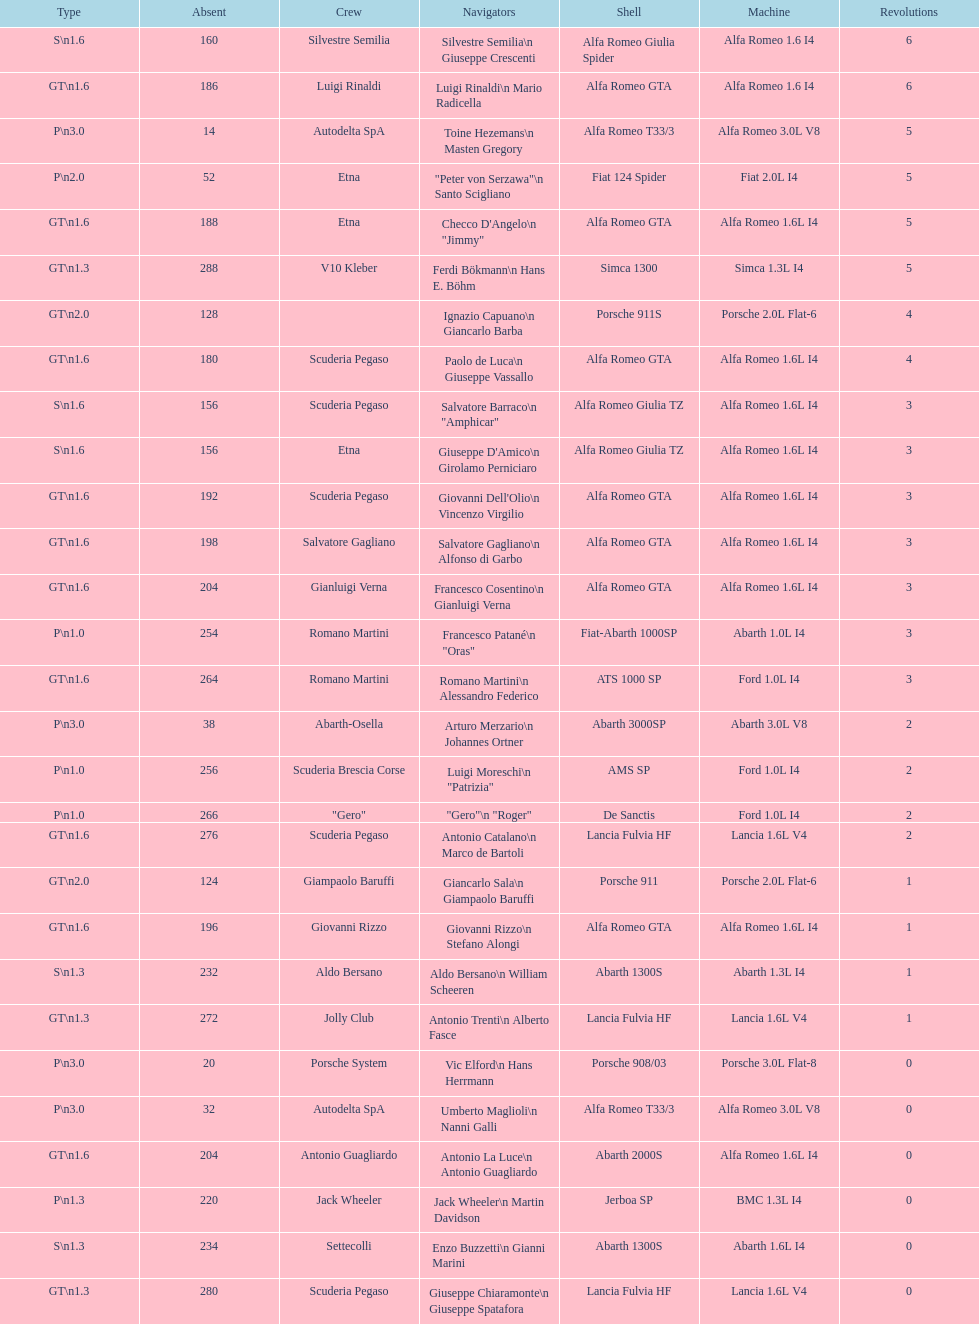Which chassis is in the middle of simca 1300 and alfa romeo gta? Porsche 911S. 